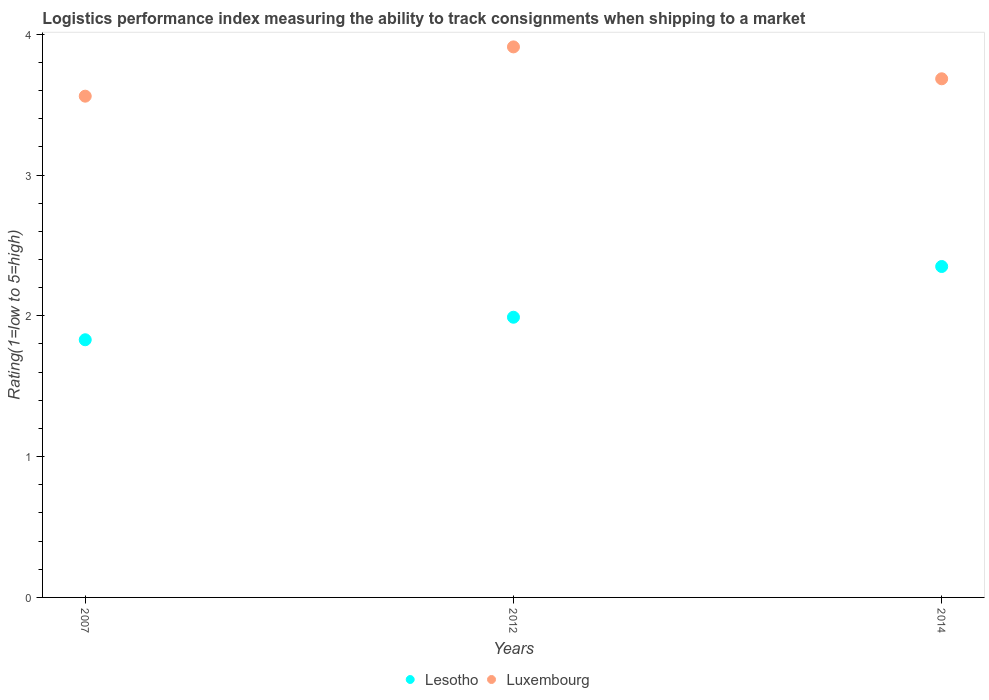How many different coloured dotlines are there?
Provide a succinct answer. 2. What is the Logistic performance index in Luxembourg in 2014?
Offer a terse response. 3.68. Across all years, what is the maximum Logistic performance index in Lesotho?
Provide a succinct answer. 2.35. Across all years, what is the minimum Logistic performance index in Lesotho?
Your answer should be compact. 1.83. In which year was the Logistic performance index in Luxembourg maximum?
Offer a very short reply. 2012. In which year was the Logistic performance index in Luxembourg minimum?
Your answer should be very brief. 2007. What is the total Logistic performance index in Luxembourg in the graph?
Your response must be concise. 11.15. What is the difference between the Logistic performance index in Lesotho in 2012 and that in 2014?
Offer a terse response. -0.36. What is the difference between the Logistic performance index in Luxembourg in 2012 and the Logistic performance index in Lesotho in 2007?
Provide a short and direct response. 2.08. What is the average Logistic performance index in Luxembourg per year?
Give a very brief answer. 3.72. In the year 2007, what is the difference between the Logistic performance index in Lesotho and Logistic performance index in Luxembourg?
Your answer should be very brief. -1.73. What is the ratio of the Logistic performance index in Luxembourg in 2007 to that in 2012?
Your response must be concise. 0.91. Is the difference between the Logistic performance index in Lesotho in 2007 and 2012 greater than the difference between the Logistic performance index in Luxembourg in 2007 and 2012?
Ensure brevity in your answer.  Yes. What is the difference between the highest and the second highest Logistic performance index in Luxembourg?
Keep it short and to the point. 0.23. What is the difference between the highest and the lowest Logistic performance index in Lesotho?
Provide a short and direct response. 0.52. Is the sum of the Logistic performance index in Luxembourg in 2007 and 2012 greater than the maximum Logistic performance index in Lesotho across all years?
Your response must be concise. Yes. How many years are there in the graph?
Ensure brevity in your answer.  3. Does the graph contain any zero values?
Give a very brief answer. No. What is the title of the graph?
Offer a terse response. Logistics performance index measuring the ability to track consignments when shipping to a market. What is the label or title of the Y-axis?
Your answer should be very brief. Rating(1=low to 5=high). What is the Rating(1=low to 5=high) in Lesotho in 2007?
Give a very brief answer. 1.83. What is the Rating(1=low to 5=high) of Luxembourg in 2007?
Make the answer very short. 3.56. What is the Rating(1=low to 5=high) of Lesotho in 2012?
Provide a succinct answer. 1.99. What is the Rating(1=low to 5=high) in Luxembourg in 2012?
Your answer should be very brief. 3.91. What is the Rating(1=low to 5=high) of Lesotho in 2014?
Ensure brevity in your answer.  2.35. What is the Rating(1=low to 5=high) in Luxembourg in 2014?
Keep it short and to the point. 3.68. Across all years, what is the maximum Rating(1=low to 5=high) of Lesotho?
Offer a very short reply. 2.35. Across all years, what is the maximum Rating(1=low to 5=high) of Luxembourg?
Ensure brevity in your answer.  3.91. Across all years, what is the minimum Rating(1=low to 5=high) in Lesotho?
Give a very brief answer. 1.83. Across all years, what is the minimum Rating(1=low to 5=high) in Luxembourg?
Offer a terse response. 3.56. What is the total Rating(1=low to 5=high) in Lesotho in the graph?
Provide a succinct answer. 6.17. What is the total Rating(1=low to 5=high) in Luxembourg in the graph?
Provide a succinct answer. 11.15. What is the difference between the Rating(1=low to 5=high) of Lesotho in 2007 and that in 2012?
Ensure brevity in your answer.  -0.16. What is the difference between the Rating(1=low to 5=high) of Luxembourg in 2007 and that in 2012?
Provide a short and direct response. -0.35. What is the difference between the Rating(1=low to 5=high) of Lesotho in 2007 and that in 2014?
Provide a short and direct response. -0.52. What is the difference between the Rating(1=low to 5=high) in Luxembourg in 2007 and that in 2014?
Make the answer very short. -0.12. What is the difference between the Rating(1=low to 5=high) of Lesotho in 2012 and that in 2014?
Provide a succinct answer. -0.36. What is the difference between the Rating(1=low to 5=high) of Luxembourg in 2012 and that in 2014?
Offer a very short reply. 0.23. What is the difference between the Rating(1=low to 5=high) of Lesotho in 2007 and the Rating(1=low to 5=high) of Luxembourg in 2012?
Your response must be concise. -2.08. What is the difference between the Rating(1=low to 5=high) in Lesotho in 2007 and the Rating(1=low to 5=high) in Luxembourg in 2014?
Your answer should be very brief. -1.85. What is the difference between the Rating(1=low to 5=high) in Lesotho in 2012 and the Rating(1=low to 5=high) in Luxembourg in 2014?
Keep it short and to the point. -1.69. What is the average Rating(1=low to 5=high) in Lesotho per year?
Your response must be concise. 2.06. What is the average Rating(1=low to 5=high) of Luxembourg per year?
Provide a succinct answer. 3.72. In the year 2007, what is the difference between the Rating(1=low to 5=high) of Lesotho and Rating(1=low to 5=high) of Luxembourg?
Keep it short and to the point. -1.73. In the year 2012, what is the difference between the Rating(1=low to 5=high) of Lesotho and Rating(1=low to 5=high) of Luxembourg?
Your response must be concise. -1.92. In the year 2014, what is the difference between the Rating(1=low to 5=high) of Lesotho and Rating(1=low to 5=high) of Luxembourg?
Your answer should be compact. -1.33. What is the ratio of the Rating(1=low to 5=high) in Lesotho in 2007 to that in 2012?
Ensure brevity in your answer.  0.92. What is the ratio of the Rating(1=low to 5=high) of Luxembourg in 2007 to that in 2012?
Keep it short and to the point. 0.91. What is the ratio of the Rating(1=low to 5=high) in Lesotho in 2007 to that in 2014?
Your answer should be compact. 0.78. What is the ratio of the Rating(1=low to 5=high) of Luxembourg in 2007 to that in 2014?
Make the answer very short. 0.97. What is the ratio of the Rating(1=low to 5=high) of Lesotho in 2012 to that in 2014?
Offer a very short reply. 0.85. What is the ratio of the Rating(1=low to 5=high) of Luxembourg in 2012 to that in 2014?
Give a very brief answer. 1.06. What is the difference between the highest and the second highest Rating(1=low to 5=high) of Lesotho?
Keep it short and to the point. 0.36. What is the difference between the highest and the second highest Rating(1=low to 5=high) of Luxembourg?
Provide a short and direct response. 0.23. What is the difference between the highest and the lowest Rating(1=low to 5=high) of Lesotho?
Ensure brevity in your answer.  0.52. 